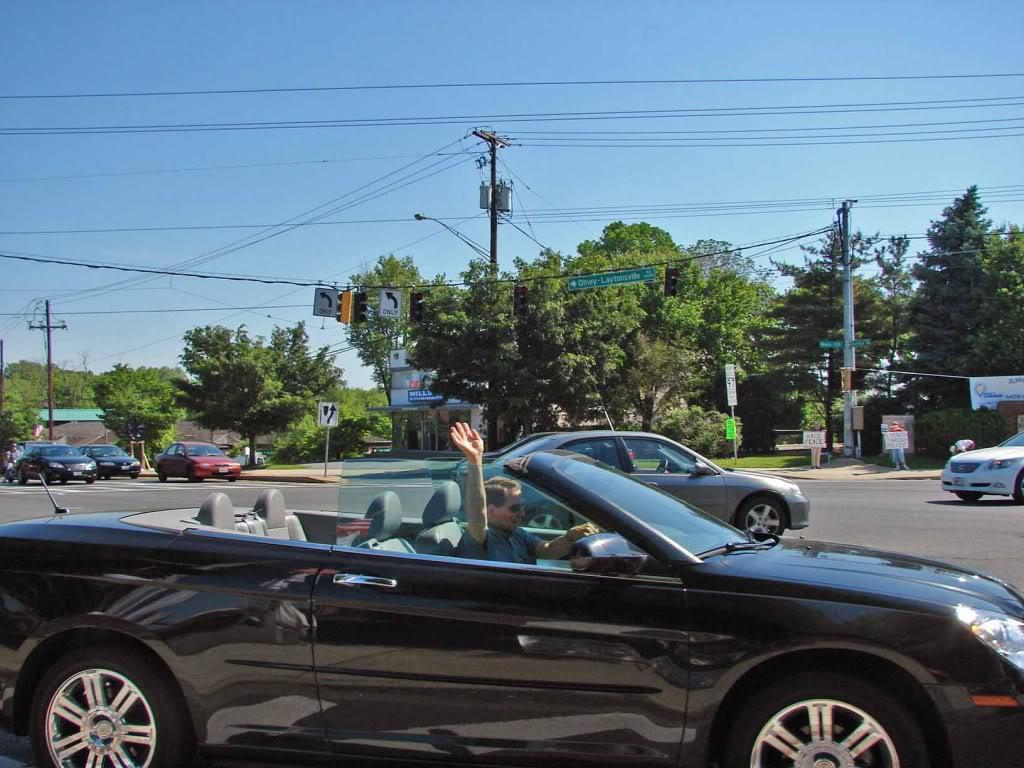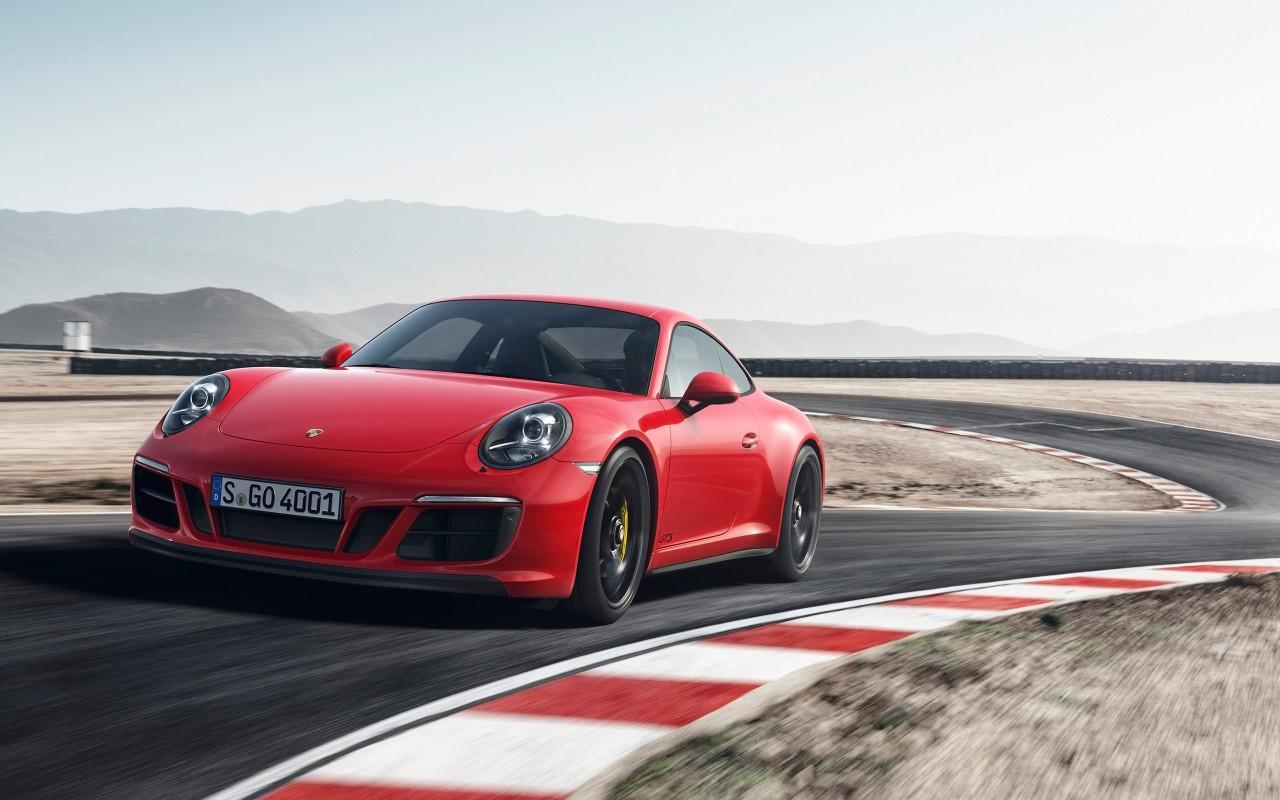The first image is the image on the left, the second image is the image on the right. For the images displayed, is the sentence "Both cars are red." factually correct? Answer yes or no. No. The first image is the image on the left, the second image is the image on the right. Considering the images on both sides, is "The right image has a convertible with the ocean visible behind it" valid? Answer yes or no. No. 